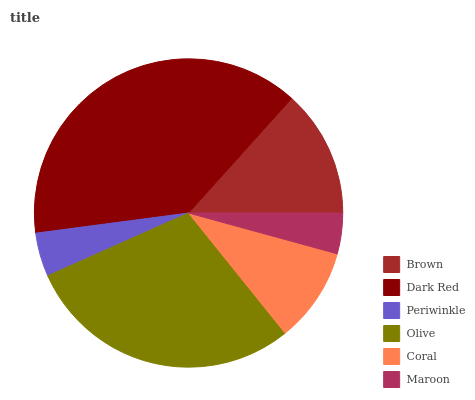Is Maroon the minimum?
Answer yes or no. Yes. Is Dark Red the maximum?
Answer yes or no. Yes. Is Periwinkle the minimum?
Answer yes or no. No. Is Periwinkle the maximum?
Answer yes or no. No. Is Dark Red greater than Periwinkle?
Answer yes or no. Yes. Is Periwinkle less than Dark Red?
Answer yes or no. Yes. Is Periwinkle greater than Dark Red?
Answer yes or no. No. Is Dark Red less than Periwinkle?
Answer yes or no. No. Is Brown the high median?
Answer yes or no. Yes. Is Coral the low median?
Answer yes or no. Yes. Is Periwinkle the high median?
Answer yes or no. No. Is Dark Red the low median?
Answer yes or no. No. 